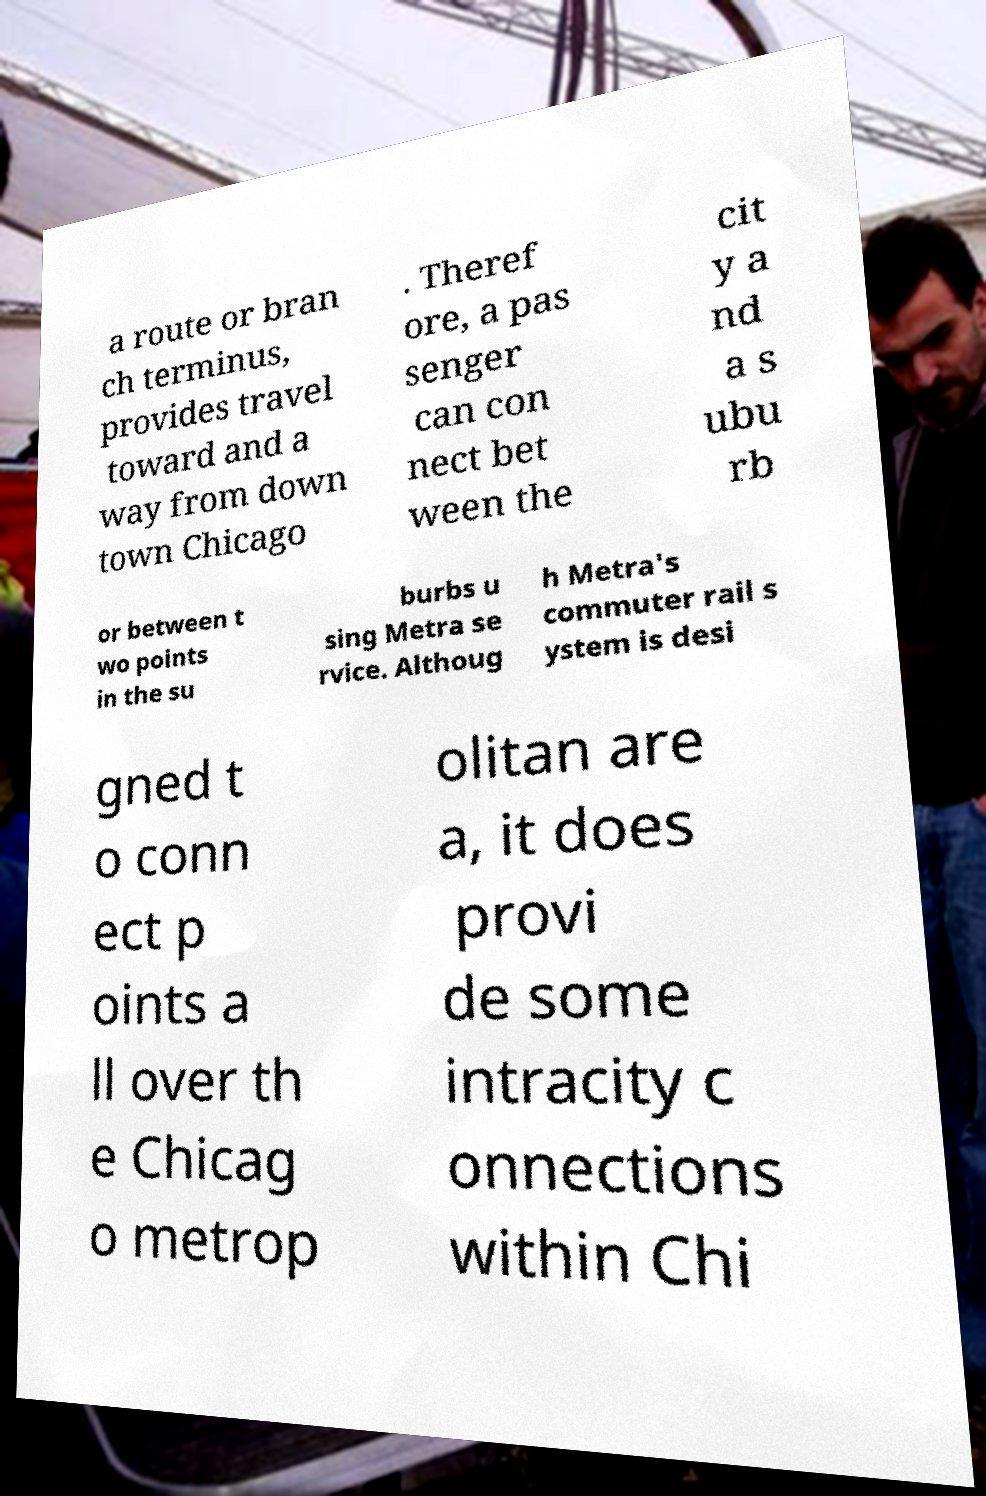What messages or text are displayed in this image? I need them in a readable, typed format. a route or bran ch terminus, provides travel toward and a way from down town Chicago . Theref ore, a pas senger can con nect bet ween the cit y a nd a s ubu rb or between t wo points in the su burbs u sing Metra se rvice. Althoug h Metra's commuter rail s ystem is desi gned t o conn ect p oints a ll over th e Chicag o metrop olitan are a, it does provi de some intracity c onnections within Chi 